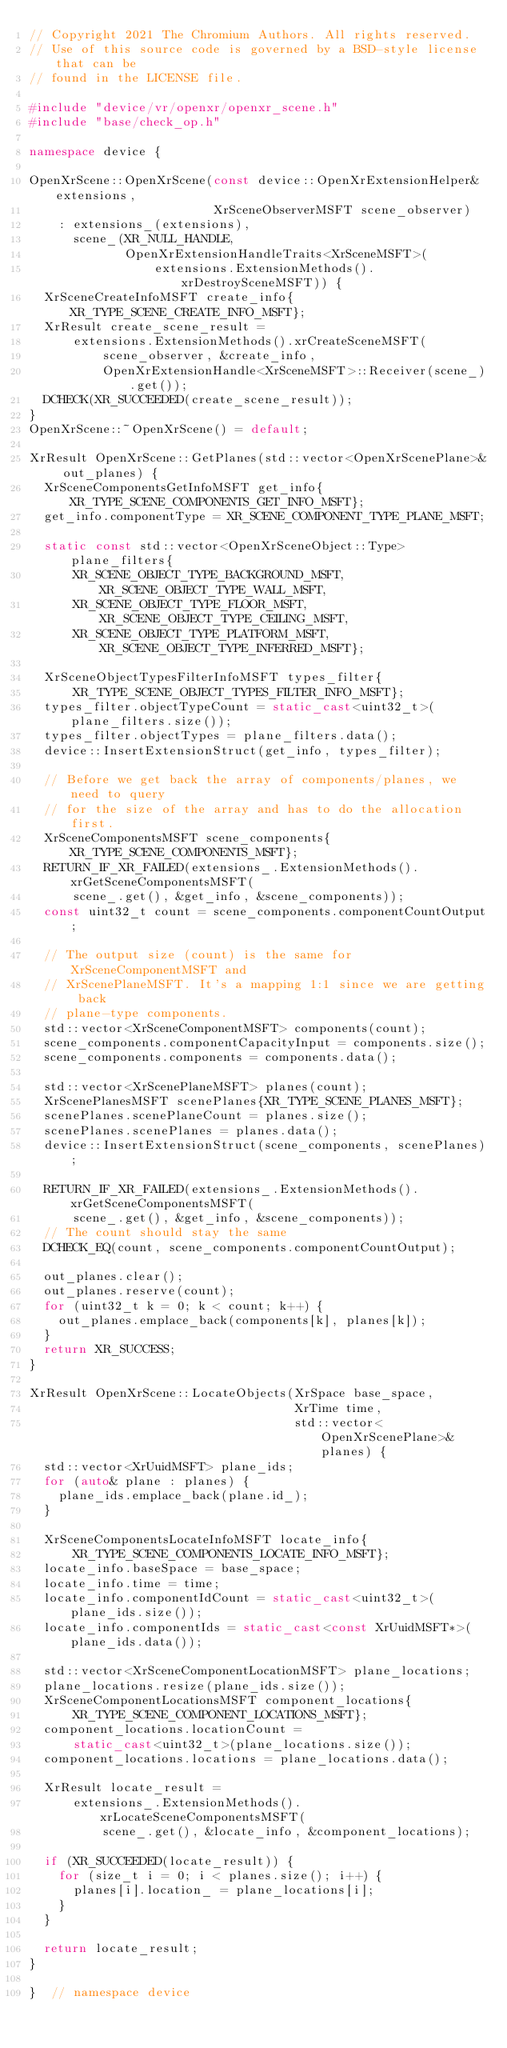<code> <loc_0><loc_0><loc_500><loc_500><_C++_>// Copyright 2021 The Chromium Authors. All rights reserved.
// Use of this source code is governed by a BSD-style license that can be
// found in the LICENSE file.

#include "device/vr/openxr/openxr_scene.h"
#include "base/check_op.h"

namespace device {

OpenXrScene::OpenXrScene(const device::OpenXrExtensionHelper& extensions,
                         XrSceneObserverMSFT scene_observer)
    : extensions_(extensions),
      scene_(XR_NULL_HANDLE,
             OpenXrExtensionHandleTraits<XrSceneMSFT>(
                 extensions.ExtensionMethods().xrDestroySceneMSFT)) {
  XrSceneCreateInfoMSFT create_info{XR_TYPE_SCENE_CREATE_INFO_MSFT};
  XrResult create_scene_result =
      extensions.ExtensionMethods().xrCreateSceneMSFT(
          scene_observer, &create_info,
          OpenXrExtensionHandle<XrSceneMSFT>::Receiver(scene_).get());
  DCHECK(XR_SUCCEEDED(create_scene_result));
}
OpenXrScene::~OpenXrScene() = default;

XrResult OpenXrScene::GetPlanes(std::vector<OpenXrScenePlane>& out_planes) {
  XrSceneComponentsGetInfoMSFT get_info{XR_TYPE_SCENE_COMPONENTS_GET_INFO_MSFT};
  get_info.componentType = XR_SCENE_COMPONENT_TYPE_PLANE_MSFT;

  static const std::vector<OpenXrSceneObject::Type> plane_filters{
      XR_SCENE_OBJECT_TYPE_BACKGROUND_MSFT, XR_SCENE_OBJECT_TYPE_WALL_MSFT,
      XR_SCENE_OBJECT_TYPE_FLOOR_MSFT,      XR_SCENE_OBJECT_TYPE_CEILING_MSFT,
      XR_SCENE_OBJECT_TYPE_PLATFORM_MSFT,   XR_SCENE_OBJECT_TYPE_INFERRED_MSFT};

  XrSceneObjectTypesFilterInfoMSFT types_filter{
      XR_TYPE_SCENE_OBJECT_TYPES_FILTER_INFO_MSFT};
  types_filter.objectTypeCount = static_cast<uint32_t>(plane_filters.size());
  types_filter.objectTypes = plane_filters.data();
  device::InsertExtensionStruct(get_info, types_filter);

  // Before we get back the array of components/planes, we need to query
  // for the size of the array and has to do the allocation first.
  XrSceneComponentsMSFT scene_components{XR_TYPE_SCENE_COMPONENTS_MSFT};
  RETURN_IF_XR_FAILED(extensions_.ExtensionMethods().xrGetSceneComponentsMSFT(
      scene_.get(), &get_info, &scene_components));
  const uint32_t count = scene_components.componentCountOutput;

  // The output size (count) is the same for XrSceneComponentMSFT and
  // XrScenePlaneMSFT. It's a mapping 1:1 since we are getting back
  // plane-type components.
  std::vector<XrSceneComponentMSFT> components(count);
  scene_components.componentCapacityInput = components.size();
  scene_components.components = components.data();

  std::vector<XrScenePlaneMSFT> planes(count);
  XrScenePlanesMSFT scenePlanes{XR_TYPE_SCENE_PLANES_MSFT};
  scenePlanes.scenePlaneCount = planes.size();
  scenePlanes.scenePlanes = planes.data();
  device::InsertExtensionStruct(scene_components, scenePlanes);

  RETURN_IF_XR_FAILED(extensions_.ExtensionMethods().xrGetSceneComponentsMSFT(
      scene_.get(), &get_info, &scene_components));
  // The count should stay the same
  DCHECK_EQ(count, scene_components.componentCountOutput);

  out_planes.clear();
  out_planes.reserve(count);
  for (uint32_t k = 0; k < count; k++) {
    out_planes.emplace_back(components[k], planes[k]);
  }
  return XR_SUCCESS;
}

XrResult OpenXrScene::LocateObjects(XrSpace base_space,
                                    XrTime time,
                                    std::vector<OpenXrScenePlane>& planes) {
  std::vector<XrUuidMSFT> plane_ids;
  for (auto& plane : planes) {
    plane_ids.emplace_back(plane.id_);
  }

  XrSceneComponentsLocateInfoMSFT locate_info{
      XR_TYPE_SCENE_COMPONENTS_LOCATE_INFO_MSFT};
  locate_info.baseSpace = base_space;
  locate_info.time = time;
  locate_info.componentIdCount = static_cast<uint32_t>(plane_ids.size());
  locate_info.componentIds = static_cast<const XrUuidMSFT*>(plane_ids.data());

  std::vector<XrSceneComponentLocationMSFT> plane_locations;
  plane_locations.resize(plane_ids.size());
  XrSceneComponentLocationsMSFT component_locations{
      XR_TYPE_SCENE_COMPONENT_LOCATIONS_MSFT};
  component_locations.locationCount =
      static_cast<uint32_t>(plane_locations.size());
  component_locations.locations = plane_locations.data();

  XrResult locate_result =
      extensions_.ExtensionMethods().xrLocateSceneComponentsMSFT(
          scene_.get(), &locate_info, &component_locations);

  if (XR_SUCCEEDED(locate_result)) {
    for (size_t i = 0; i < planes.size(); i++) {
      planes[i].location_ = plane_locations[i];
    }
  }

  return locate_result;
}

}  // namespace device
</code> 